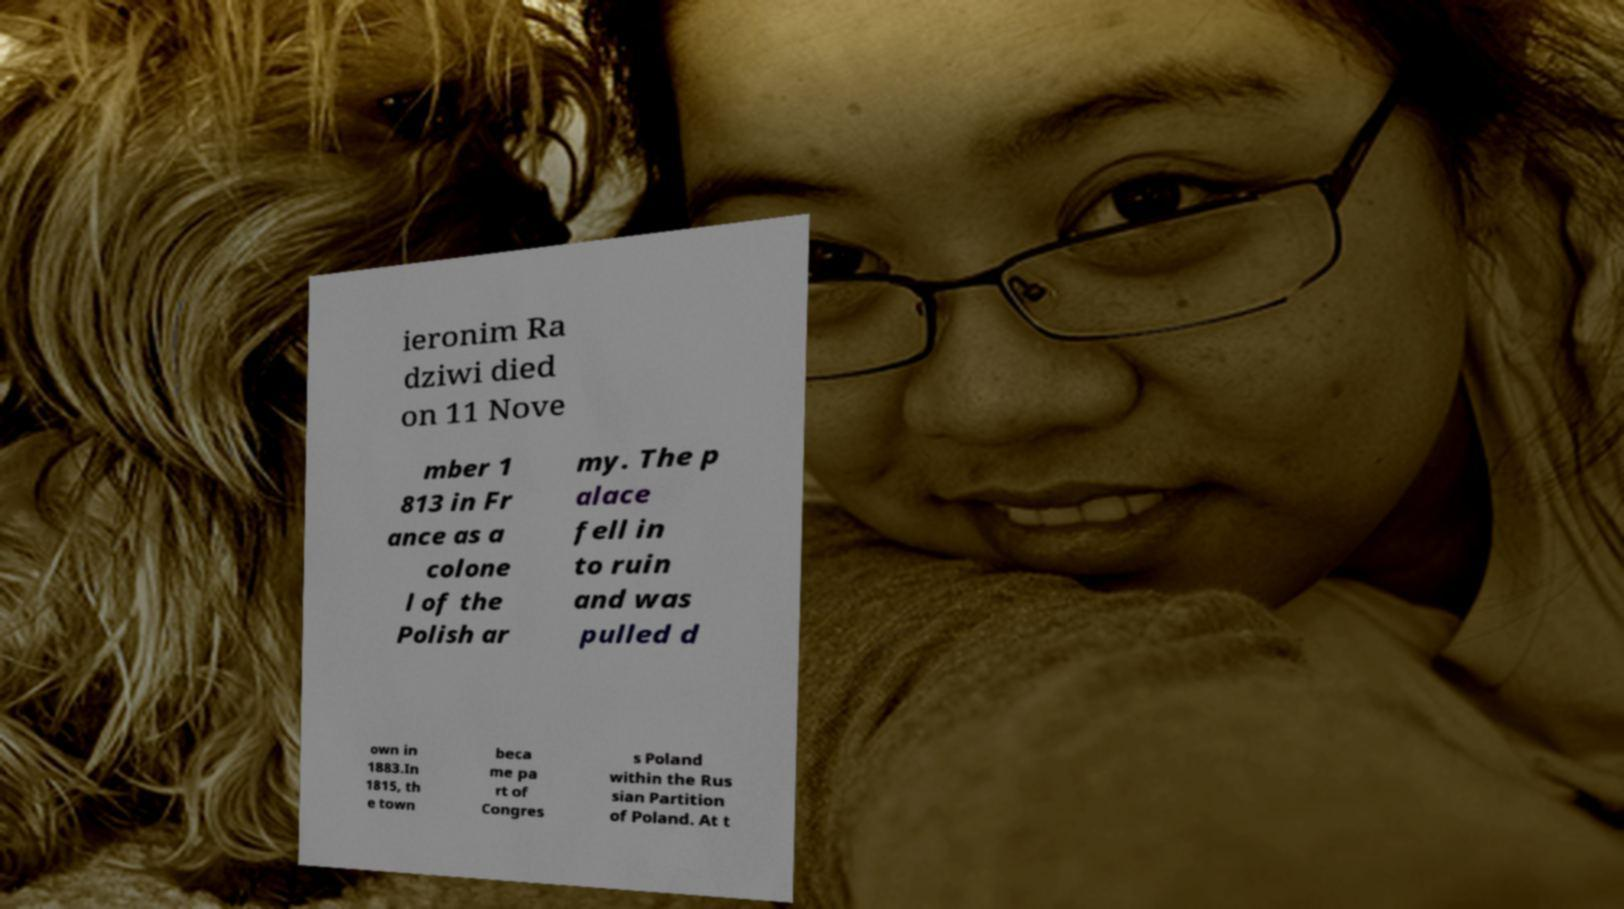Can you read and provide the text displayed in the image?This photo seems to have some interesting text. Can you extract and type it out for me? ieronim Ra dziwi died on 11 Nove mber 1 813 in Fr ance as a colone l of the Polish ar my. The p alace fell in to ruin and was pulled d own in 1883.In 1815, th e town beca me pa rt of Congres s Poland within the Rus sian Partition of Poland. At t 